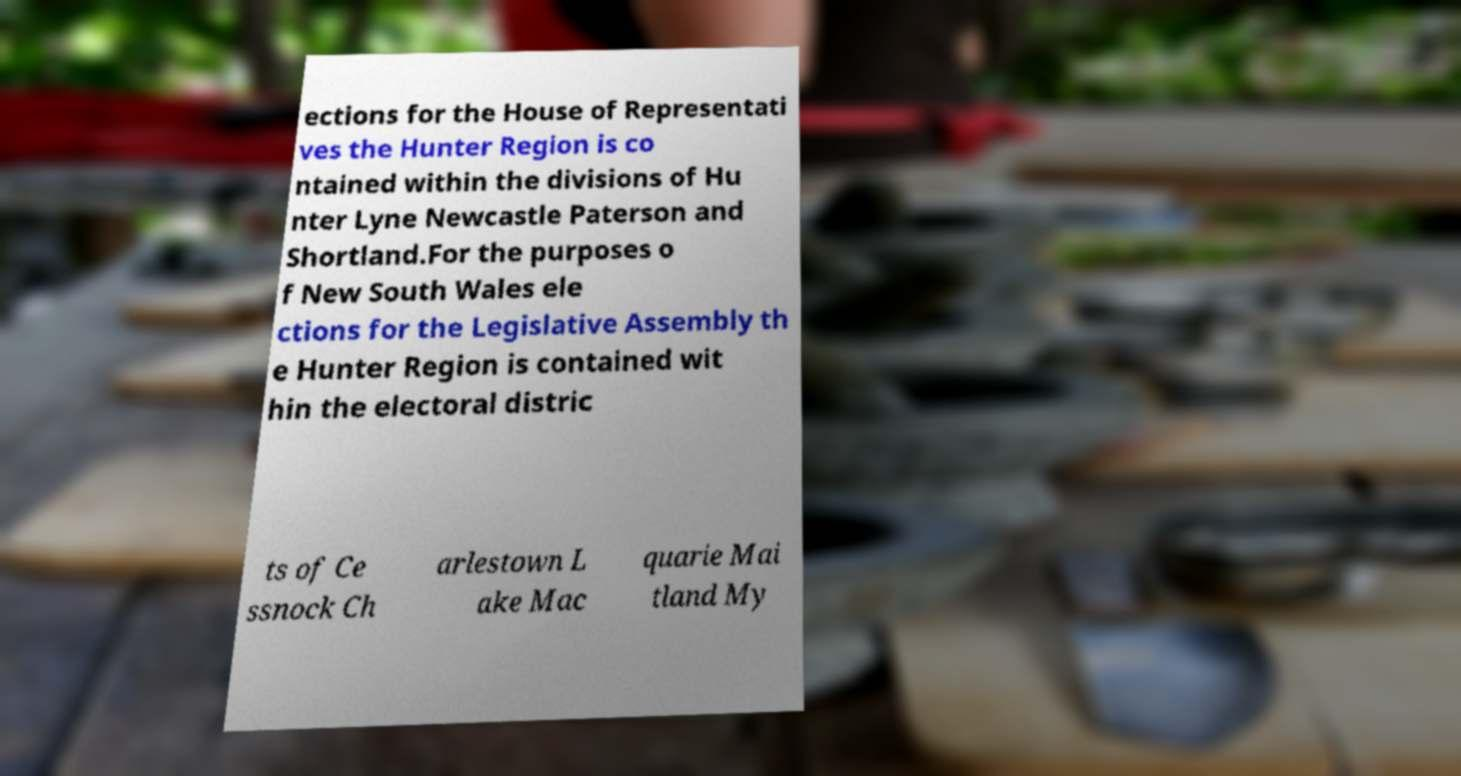There's text embedded in this image that I need extracted. Can you transcribe it verbatim? ections for the House of Representati ves the Hunter Region is co ntained within the divisions of Hu nter Lyne Newcastle Paterson and Shortland.For the purposes o f New South Wales ele ctions for the Legislative Assembly th e Hunter Region is contained wit hin the electoral distric ts of Ce ssnock Ch arlestown L ake Mac quarie Mai tland My 